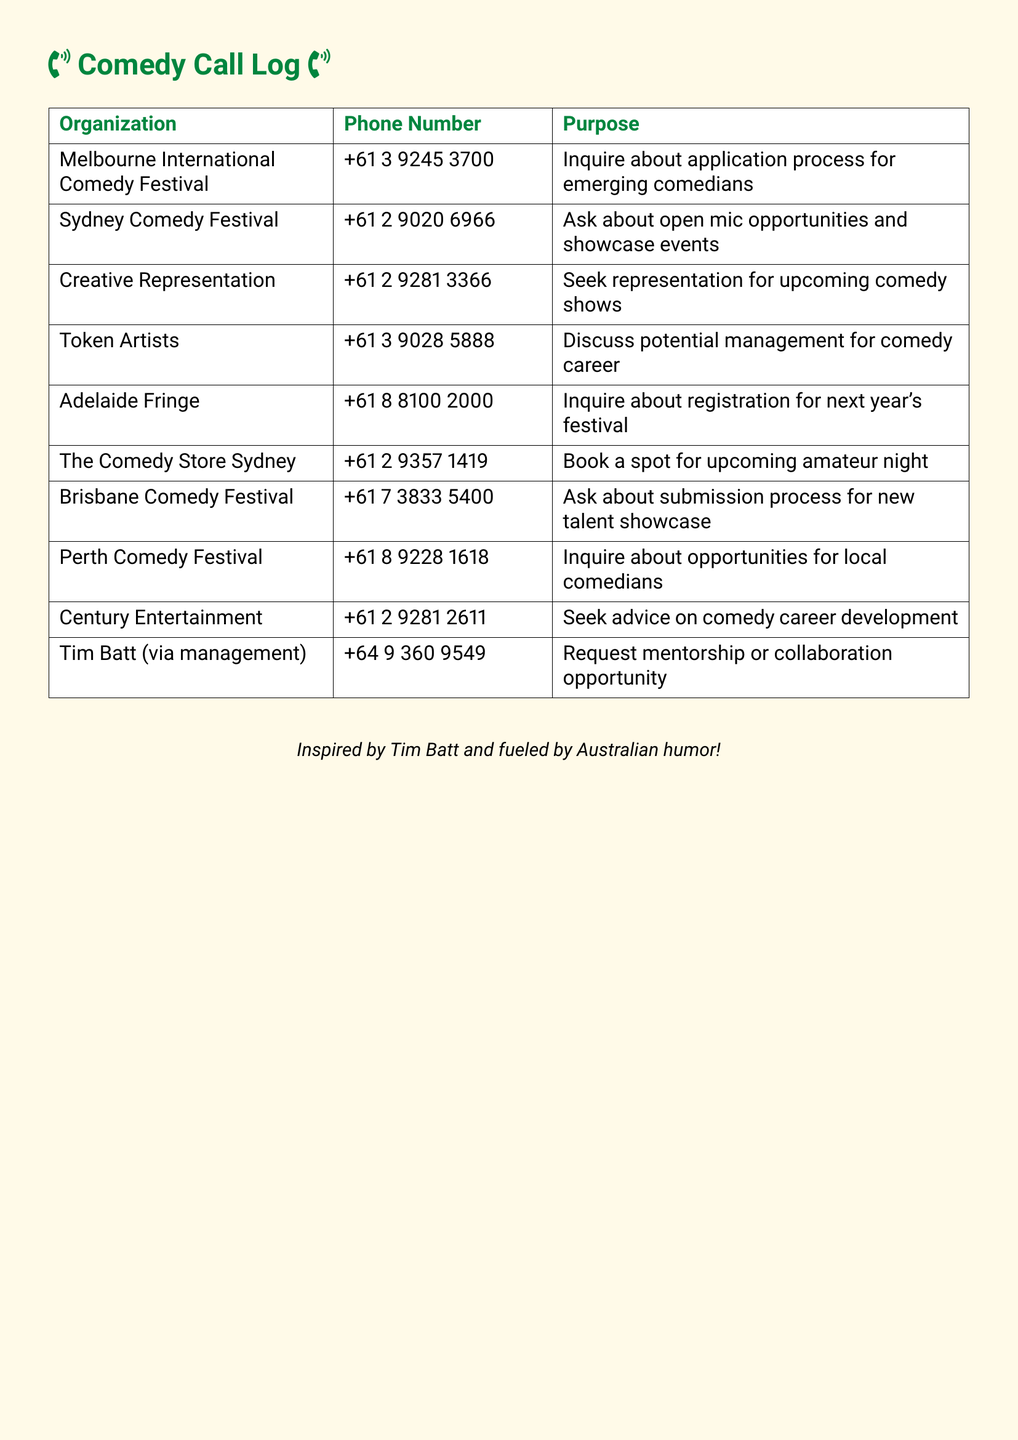What is the phone number for the Melbourne International Comedy Festival? The phone number is directly listed in the document.
Answer: +61 3 9245 3700 Who did you contact for mentorship opportunities? The document specifies the organization and management related to mentorship.
Answer: Tim Batt (via management) What is the purpose of the call to Creative Representation? The purpose is explicitly stated in the document next to the organization.
Answer: Seek representation for upcoming comedy shows Which comedy festival is located in Sydney? The document lists multiple organizations with their respective locations, identifying the Sydney comedy festival.
Answer: Sydney Comedy Festival How many different organizations were contacted? This can be determined by counting the unique organizations listed in the table.
Answer: 10 What was inquired about during the call to the Adelaide Fringe? The document indicates the specific inquiry made to the organization.
Answer: Registration for next year's festival What is the main focus of the call to Brisbane Comedy Festival? The document clearly outlines the topic of the inquiry made to this organization.
Answer: Submission process for new talent showcase Which organization is associated with potential management discussions? The document names the organization that is involved in management discussions.
Answer: Token Artists 